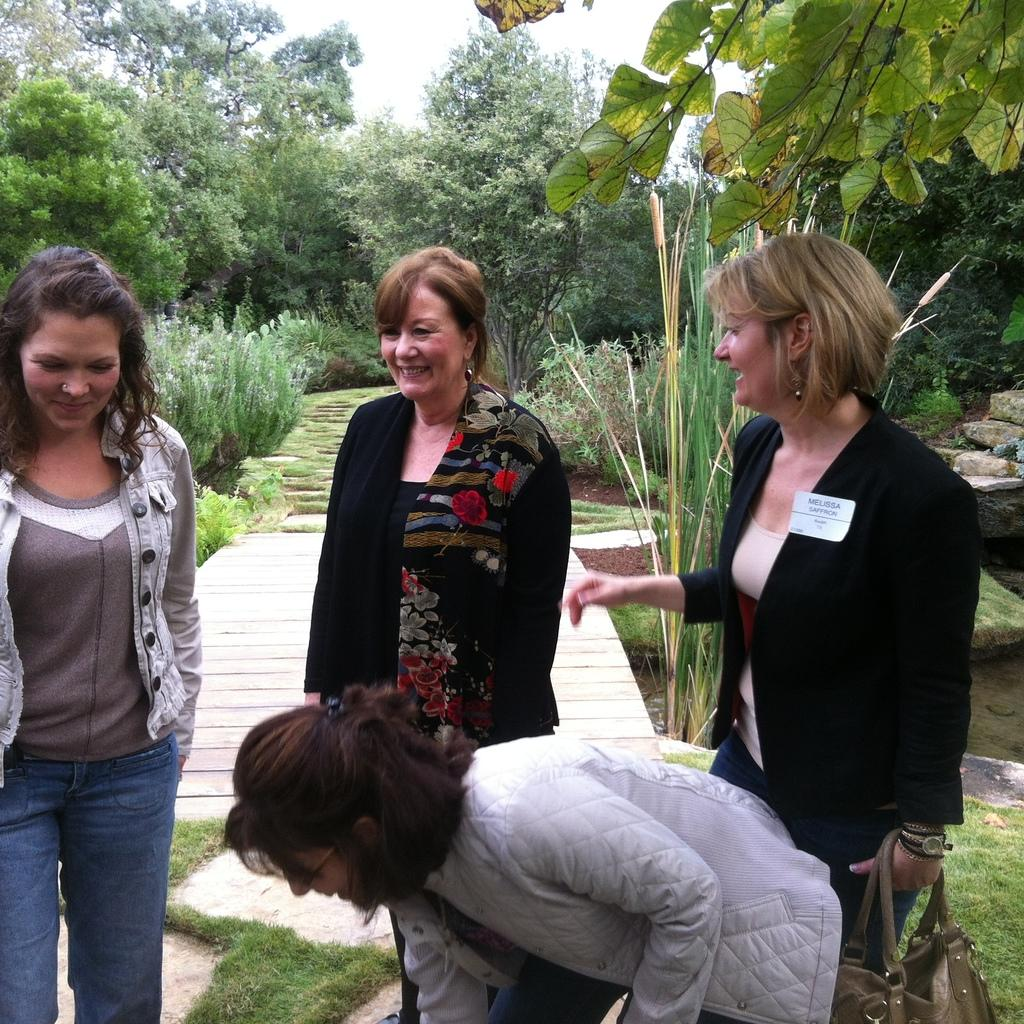How many women are in the image? There are four women in the foreground of the image. Where are the women located in the image? The women are on the road. What can be seen in the background of the image? There is a bridge, grass, trees, and the sky visible in the background of the image. When was the image taken? The image was taken during the day. What type of cracker is being fed to the pigs in the image? There are no pigs or crackers present in the image. 